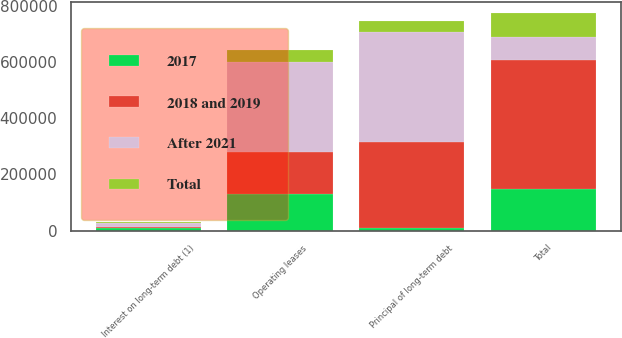Convert chart. <chart><loc_0><loc_0><loc_500><loc_500><stacked_bar_chart><ecel><fcel>Principal of long-term debt<fcel>Interest on long-term debt (1)<fcel>Operating leases<fcel>Total<nl><fcel>After 2021<fcel>390000<fcel>15745<fcel>321382<fcel>84881<nl><fcel>2017<fcel>10482<fcel>7676<fcel>129445<fcel>147603<nl><fcel>2018 and 2019<fcel>304518<fcel>4311<fcel>148785<fcel>457614<nl><fcel>Total<fcel>40000<fcel>3115<fcel>41766<fcel>84881<nl></chart> 